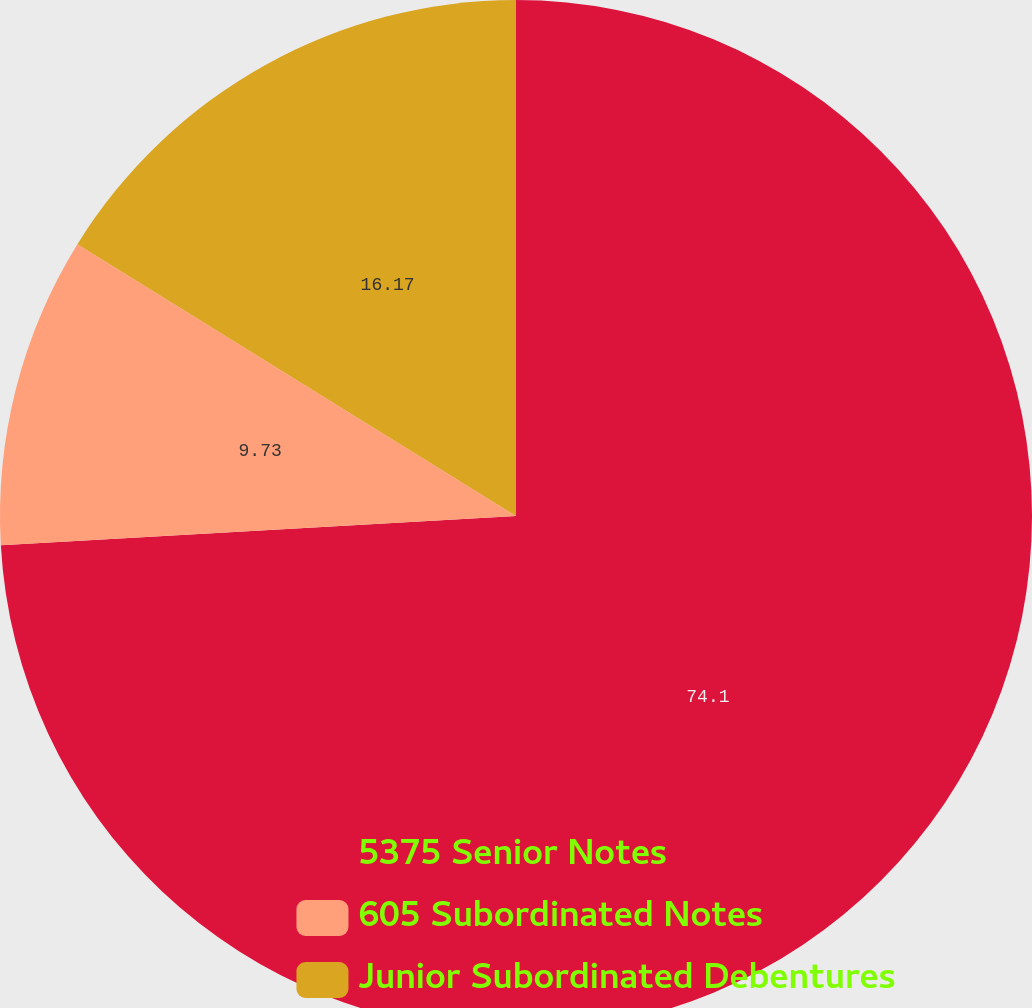<chart> <loc_0><loc_0><loc_500><loc_500><pie_chart><fcel>5375 Senior Notes<fcel>605 Subordinated Notes<fcel>Junior Subordinated Debentures<nl><fcel>74.1%<fcel>9.73%<fcel>16.17%<nl></chart> 